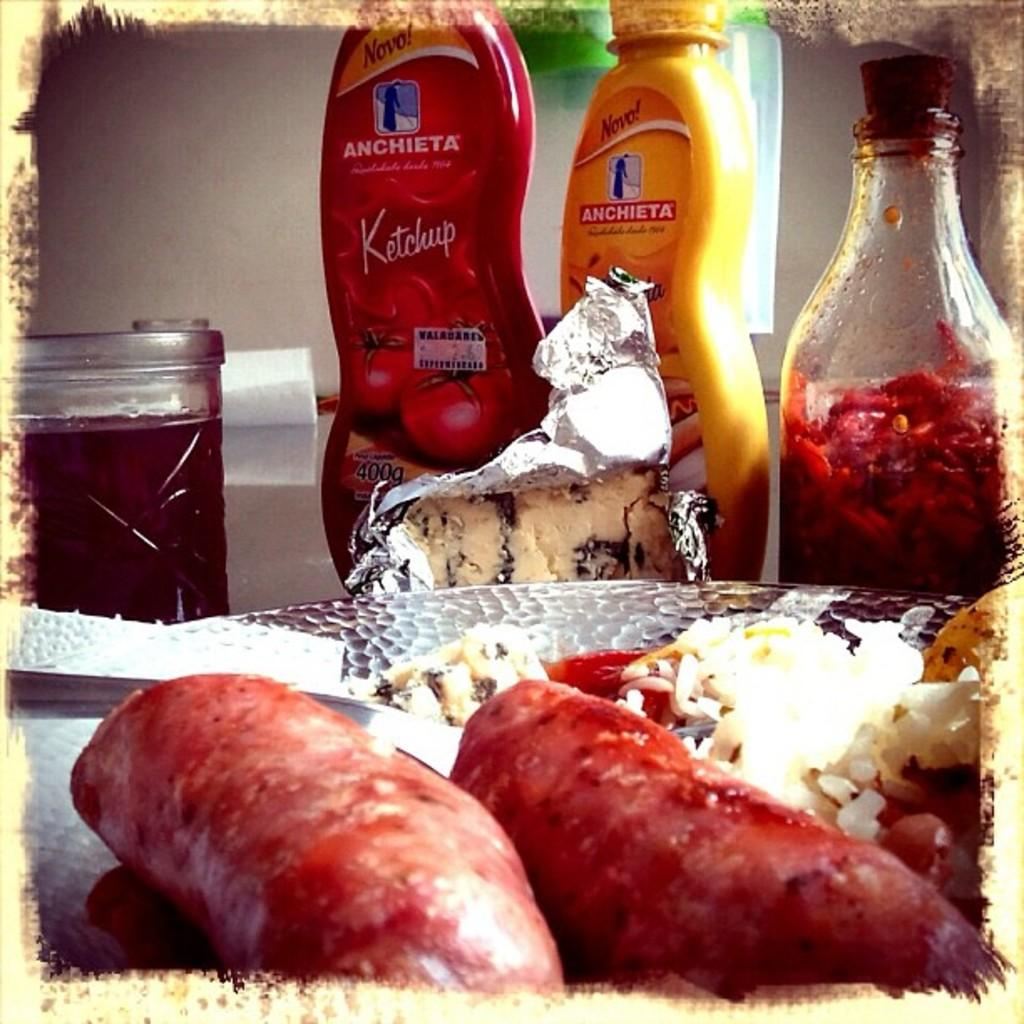What is the main subject in the foreground of the image? There is a food item in the foreground of the image. What can be seen in the middle of the image? There are bottles and a container on a white surface in the middle of the image. What is visible in the background of the image? There is a wall in the background of the image. What type of gold example can be seen on the wall in the image? There is no gold example present on the wall in the image. Can you tell me how many apples are on the white surface in the image? There is no apple present on the white surface in the image. 